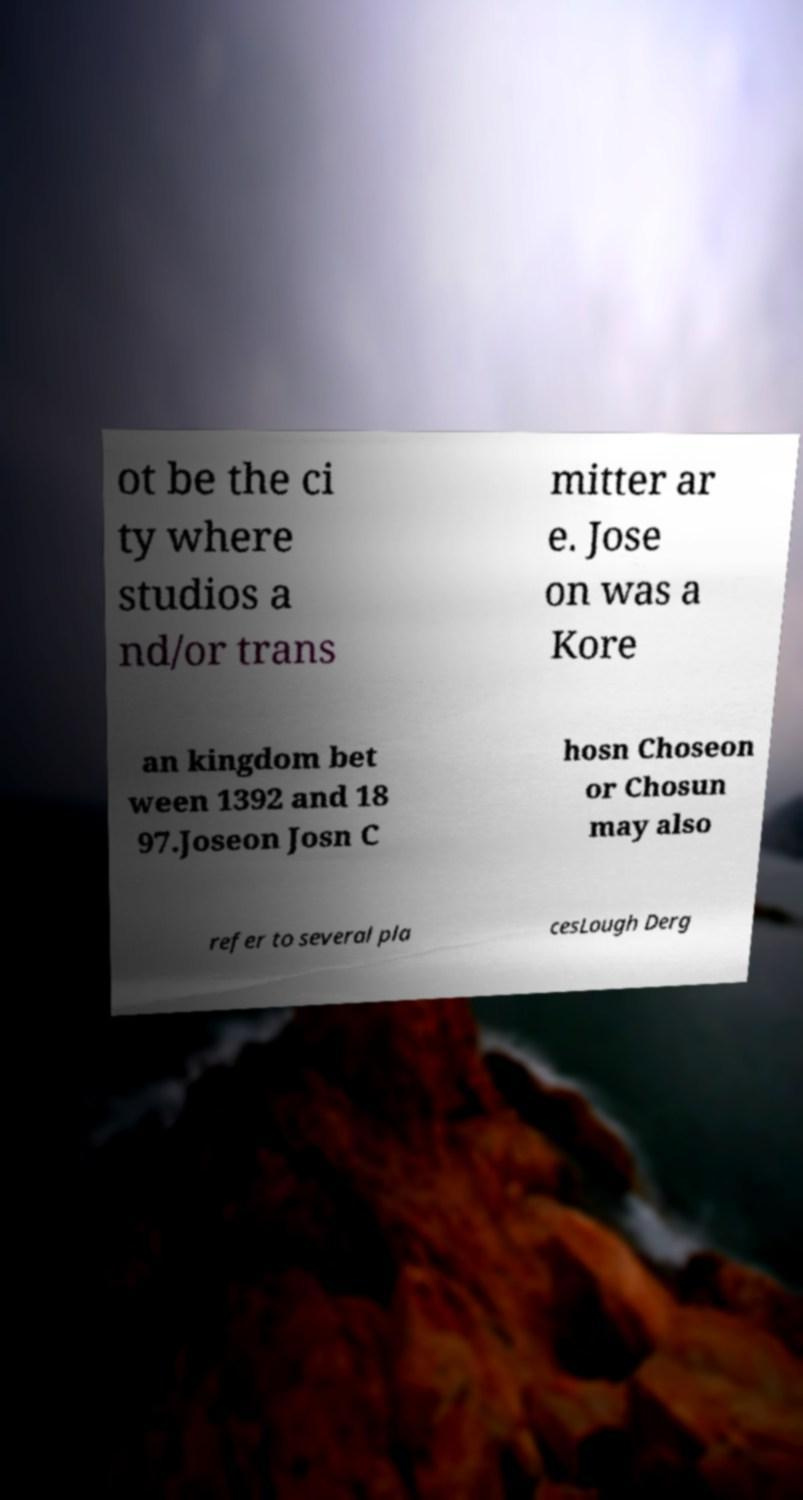Please identify and transcribe the text found in this image. ot be the ci ty where studios a nd/or trans mitter ar e. Jose on was a Kore an kingdom bet ween 1392 and 18 97.Joseon Josn C hosn Choseon or Chosun may also refer to several pla cesLough Derg 